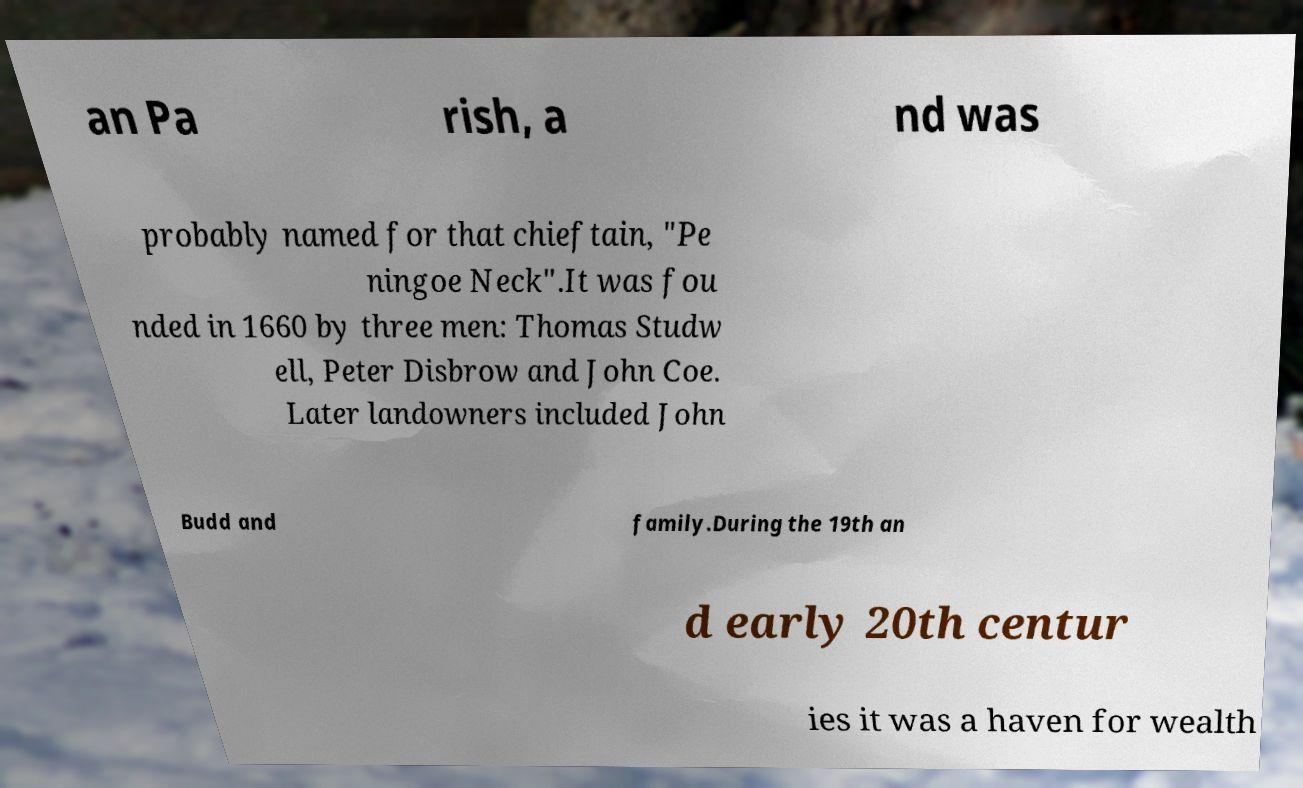Please identify and transcribe the text found in this image. an Pa rish, a nd was probably named for that chieftain, "Pe ningoe Neck".It was fou nded in 1660 by three men: Thomas Studw ell, Peter Disbrow and John Coe. Later landowners included John Budd and family.During the 19th an d early 20th centur ies it was a haven for wealth 